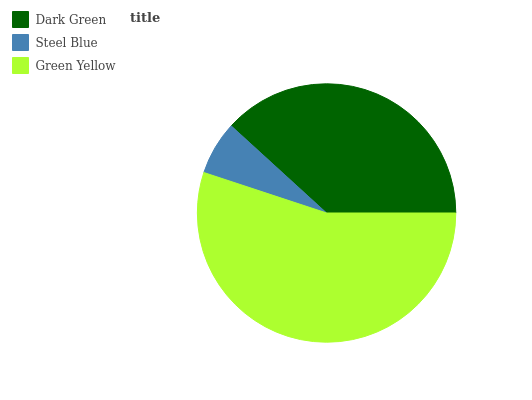Is Steel Blue the minimum?
Answer yes or no. Yes. Is Green Yellow the maximum?
Answer yes or no. Yes. Is Green Yellow the minimum?
Answer yes or no. No. Is Steel Blue the maximum?
Answer yes or no. No. Is Green Yellow greater than Steel Blue?
Answer yes or no. Yes. Is Steel Blue less than Green Yellow?
Answer yes or no. Yes. Is Steel Blue greater than Green Yellow?
Answer yes or no. No. Is Green Yellow less than Steel Blue?
Answer yes or no. No. Is Dark Green the high median?
Answer yes or no. Yes. Is Dark Green the low median?
Answer yes or no. Yes. Is Steel Blue the high median?
Answer yes or no. No. Is Green Yellow the low median?
Answer yes or no. No. 